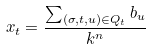Convert formula to latex. <formula><loc_0><loc_0><loc_500><loc_500>x _ { t } = \frac { \sum _ { ( \sigma , t , u ) \in Q _ { t } } { b _ { u } } } { k ^ { n } }</formula> 